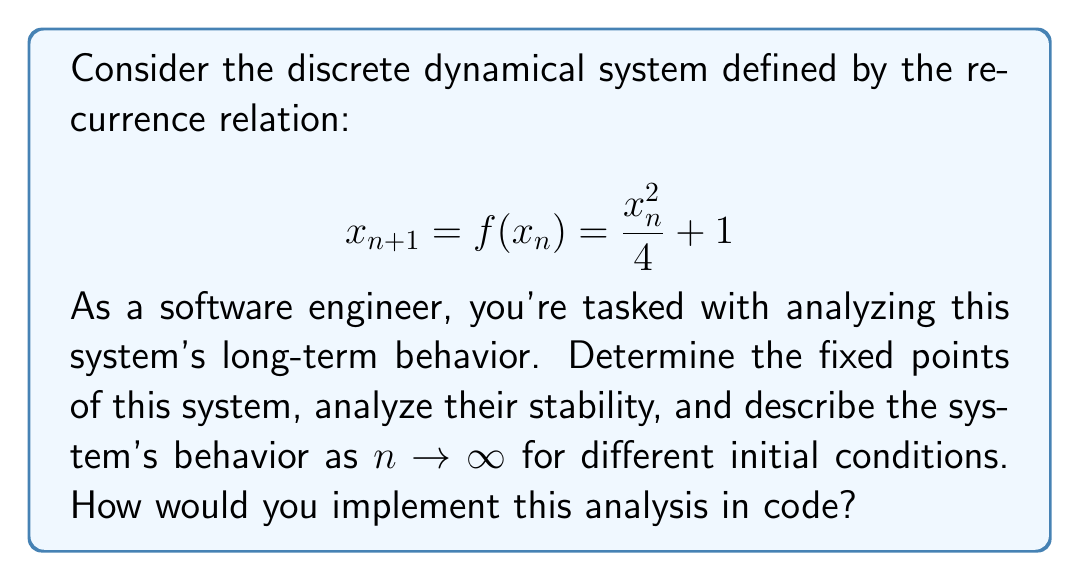Help me with this question. Let's approach this step-by-step:

1. Find the fixed points:
   Fixed points occur when $x_{n+1} = x_n = x^*$. So we solve:
   $$ x^* = \frac{(x^*)^2}{4} + 1 $$
   $$ 4x^* = (x^*)^2 + 4 $$
   $$ (x^*)^2 - 4x^* + 4 = 0 $$
   $$ (x^* - 2)^2 = 0 $$
   Therefore, the only fixed point is $x^* = 2$.

2. Analyze stability:
   To determine stability, we calculate $|f'(x^*)|$:
   $$ f'(x) = \frac{x}{2} $$
   $$ f'(2) = 1 $$
   Since $|f'(2)| = 1$, this is a non-hyperbolic fixed point, and we can't determine stability from this method alone.

3. Analyze behavior near the fixed point:
   Let's consider $x_n = 2 + \epsilon_n$, where $\epsilon_n$ is small:
   $$ x_{n+1} = f(2 + \epsilon_n) = \frac{(2 + \epsilon_n)^2}{4} + 1 $$
   $$ = \frac{4 + 4\epsilon_n + \epsilon_n^2}{4} + 1 $$
   $$ = 2 + \epsilon_n + \frac{\epsilon_n^2}{4} $$
   So, $\epsilon_{n+1} = \epsilon_n + \frac{\epsilon_n^2}{4}$

4. Analyze long-term behavior:
   - If $\epsilon_n > 0$, then $\epsilon_{n+1} > \epsilon_n$, so $x_n$ will grow away from 2.
   - If $\epsilon_n < 0$, then $\epsilon_{n+1} < \epsilon_n$, so $x_n$ will approach 2.
   - If $x_n = 2$ exactly, it will stay at 2.

5. Global behavior:
   - For $x_0 > 2$, the sequence will diverge to infinity.
   - For $0 < x_0 < 2$, the sequence will converge to 2.
   - For $x_0 < 0$, the sequence will eventually become complex (undefined in real numbers).

To implement this in code, you could create a function that takes an initial condition and number of iterations, then returns the sequence of values. You could also implement functions to find fixed points numerically and analyze stability.
Answer: Fixed point at $x^* = 2$; semi-stable. Converges to 2 for $0 < x_0 < 2$, diverges for $x_0 > 2$, undefined for $x_0 < 0$. 